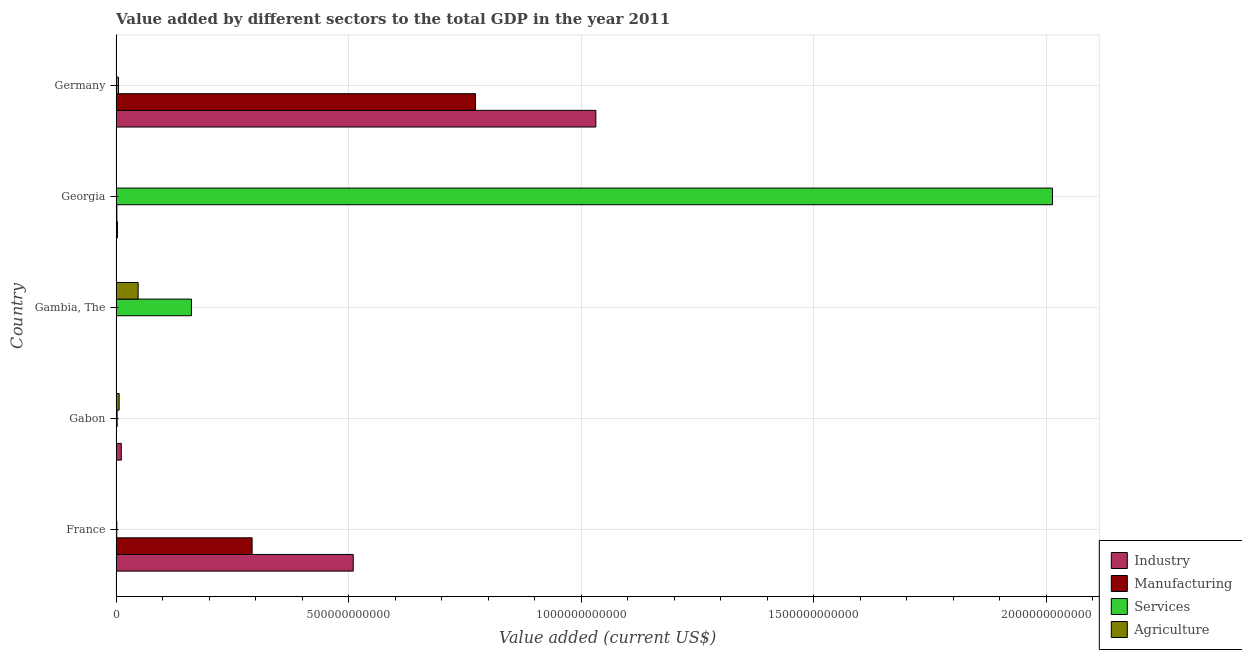How many groups of bars are there?
Your response must be concise. 5. Are the number of bars per tick equal to the number of legend labels?
Make the answer very short. Yes. Are the number of bars on each tick of the Y-axis equal?
Your answer should be very brief. Yes. In how many cases, is the number of bars for a given country not equal to the number of legend labels?
Your answer should be compact. 0. What is the value added by manufacturing sector in Gambia, The?
Provide a short and direct response. 4.95e+07. Across all countries, what is the maximum value added by industrial sector?
Your answer should be very brief. 1.03e+12. Across all countries, what is the minimum value added by industrial sector?
Offer a very short reply. 1.26e+08. In which country was the value added by agricultural sector maximum?
Your response must be concise. Gambia, The. In which country was the value added by services sector minimum?
Your answer should be very brief. France. What is the total value added by agricultural sector in the graph?
Provide a succinct answer. 5.50e+1. What is the difference between the value added by services sector in Georgia and that in Germany?
Your response must be concise. 2.01e+12. What is the difference between the value added by manufacturing sector in Gambia, The and the value added by agricultural sector in Germany?
Your answer should be very brief. -1.52e+08. What is the average value added by industrial sector per country?
Keep it short and to the point. 3.11e+11. What is the difference between the value added by industrial sector and value added by agricultural sector in France?
Your answer should be compact. 5.10e+11. In how many countries, is the value added by manufacturing sector greater than 1000000000000 US$?
Your response must be concise. 0. What is the ratio of the value added by agricultural sector in Gambia, The to that in Georgia?
Your answer should be very brief. 75.81. Is the difference between the value added by agricultural sector in France and Gabon greater than the difference between the value added by services sector in France and Gabon?
Your answer should be compact. No. What is the difference between the highest and the second highest value added by agricultural sector?
Give a very brief answer. 4.09e+1. What is the difference between the highest and the lowest value added by agricultural sector?
Give a very brief answer. 4.71e+1. Is the sum of the value added by agricultural sector in Gambia, The and Germany greater than the maximum value added by services sector across all countries?
Provide a succinct answer. No. What does the 1st bar from the top in Gabon represents?
Offer a very short reply. Agriculture. What does the 4th bar from the bottom in Georgia represents?
Your answer should be compact. Agriculture. How many bars are there?
Give a very brief answer. 20. How many countries are there in the graph?
Provide a short and direct response. 5. What is the difference between two consecutive major ticks on the X-axis?
Make the answer very short. 5.00e+11. Does the graph contain any zero values?
Offer a terse response. No. Does the graph contain grids?
Provide a succinct answer. Yes. How are the legend labels stacked?
Offer a terse response. Vertical. What is the title of the graph?
Your response must be concise. Value added by different sectors to the total GDP in the year 2011. What is the label or title of the X-axis?
Your response must be concise. Value added (current US$). What is the Value added (current US$) of Industry in France?
Give a very brief answer. 5.10e+11. What is the Value added (current US$) in Manufacturing in France?
Offer a terse response. 2.92e+11. What is the Value added (current US$) of Services in France?
Offer a terse response. 1.45e+09. What is the Value added (current US$) in Agriculture in France?
Offer a very short reply. 3.48e+08. What is the Value added (current US$) of Industry in Gabon?
Offer a very short reply. 1.11e+1. What is the Value added (current US$) of Manufacturing in Gabon?
Your answer should be compact. 3.98e+08. What is the Value added (current US$) in Services in Gabon?
Provide a succinct answer. 2.20e+09. What is the Value added (current US$) of Agriculture in Gabon?
Provide a short and direct response. 6.46e+09. What is the Value added (current US$) of Industry in Gambia, The?
Make the answer very short. 1.26e+08. What is the Value added (current US$) of Manufacturing in Gambia, The?
Make the answer very short. 4.95e+07. What is the Value added (current US$) in Services in Gambia, The?
Provide a short and direct response. 1.62e+11. What is the Value added (current US$) of Agriculture in Gambia, The?
Offer a terse response. 4.73e+1. What is the Value added (current US$) in Industry in Georgia?
Make the answer very short. 2.87e+09. What is the Value added (current US$) of Manufacturing in Georgia?
Your response must be concise. 1.63e+09. What is the Value added (current US$) in Services in Georgia?
Provide a short and direct response. 2.01e+12. What is the Value added (current US$) in Agriculture in Georgia?
Offer a terse response. 6.24e+08. What is the Value added (current US$) in Industry in Germany?
Your response must be concise. 1.03e+12. What is the Value added (current US$) of Manufacturing in Germany?
Keep it short and to the point. 7.73e+11. What is the Value added (current US$) of Services in Germany?
Your response must be concise. 5.01e+09. What is the Value added (current US$) of Agriculture in Germany?
Your answer should be compact. 2.02e+08. Across all countries, what is the maximum Value added (current US$) of Industry?
Your answer should be very brief. 1.03e+12. Across all countries, what is the maximum Value added (current US$) in Manufacturing?
Ensure brevity in your answer.  7.73e+11. Across all countries, what is the maximum Value added (current US$) of Services?
Provide a short and direct response. 2.01e+12. Across all countries, what is the maximum Value added (current US$) in Agriculture?
Make the answer very short. 4.73e+1. Across all countries, what is the minimum Value added (current US$) of Industry?
Provide a short and direct response. 1.26e+08. Across all countries, what is the minimum Value added (current US$) in Manufacturing?
Provide a short and direct response. 4.95e+07. Across all countries, what is the minimum Value added (current US$) in Services?
Your response must be concise. 1.45e+09. Across all countries, what is the minimum Value added (current US$) in Agriculture?
Keep it short and to the point. 2.02e+08. What is the total Value added (current US$) of Industry in the graph?
Make the answer very short. 1.56e+12. What is the total Value added (current US$) of Manufacturing in the graph?
Your response must be concise. 1.07e+12. What is the total Value added (current US$) of Services in the graph?
Ensure brevity in your answer.  2.18e+12. What is the total Value added (current US$) in Agriculture in the graph?
Keep it short and to the point. 5.50e+1. What is the difference between the Value added (current US$) in Industry in France and that in Gabon?
Make the answer very short. 4.99e+11. What is the difference between the Value added (current US$) in Manufacturing in France and that in Gabon?
Make the answer very short. 2.92e+11. What is the difference between the Value added (current US$) of Services in France and that in Gabon?
Offer a terse response. -7.50e+08. What is the difference between the Value added (current US$) of Agriculture in France and that in Gabon?
Your answer should be compact. -6.11e+09. What is the difference between the Value added (current US$) in Industry in France and that in Gambia, The?
Offer a terse response. 5.10e+11. What is the difference between the Value added (current US$) of Manufacturing in France and that in Gambia, The?
Your answer should be very brief. 2.92e+11. What is the difference between the Value added (current US$) of Services in France and that in Gambia, The?
Keep it short and to the point. -1.61e+11. What is the difference between the Value added (current US$) in Agriculture in France and that in Gambia, The?
Make the answer very short. -4.70e+1. What is the difference between the Value added (current US$) of Industry in France and that in Georgia?
Provide a short and direct response. 5.07e+11. What is the difference between the Value added (current US$) of Manufacturing in France and that in Georgia?
Keep it short and to the point. 2.91e+11. What is the difference between the Value added (current US$) in Services in France and that in Georgia?
Make the answer very short. -2.01e+12. What is the difference between the Value added (current US$) of Agriculture in France and that in Georgia?
Ensure brevity in your answer.  -2.76e+08. What is the difference between the Value added (current US$) in Industry in France and that in Germany?
Provide a short and direct response. -5.22e+11. What is the difference between the Value added (current US$) of Manufacturing in France and that in Germany?
Offer a very short reply. -4.80e+11. What is the difference between the Value added (current US$) in Services in France and that in Germany?
Offer a very short reply. -3.56e+09. What is the difference between the Value added (current US$) in Agriculture in France and that in Germany?
Keep it short and to the point. 1.46e+08. What is the difference between the Value added (current US$) in Industry in Gabon and that in Gambia, The?
Make the answer very short. 1.09e+1. What is the difference between the Value added (current US$) in Manufacturing in Gabon and that in Gambia, The?
Keep it short and to the point. 3.48e+08. What is the difference between the Value added (current US$) in Services in Gabon and that in Gambia, The?
Offer a terse response. -1.60e+11. What is the difference between the Value added (current US$) of Agriculture in Gabon and that in Gambia, The?
Keep it short and to the point. -4.09e+1. What is the difference between the Value added (current US$) in Industry in Gabon and that in Georgia?
Provide a succinct answer. 8.20e+09. What is the difference between the Value added (current US$) of Manufacturing in Gabon and that in Georgia?
Offer a very short reply. -1.23e+09. What is the difference between the Value added (current US$) of Services in Gabon and that in Georgia?
Your answer should be compact. -2.01e+12. What is the difference between the Value added (current US$) in Agriculture in Gabon and that in Georgia?
Your response must be concise. 5.84e+09. What is the difference between the Value added (current US$) of Industry in Gabon and that in Germany?
Your response must be concise. -1.02e+12. What is the difference between the Value added (current US$) of Manufacturing in Gabon and that in Germany?
Give a very brief answer. -7.72e+11. What is the difference between the Value added (current US$) of Services in Gabon and that in Germany?
Provide a succinct answer. -2.81e+09. What is the difference between the Value added (current US$) in Agriculture in Gabon and that in Germany?
Provide a succinct answer. 6.26e+09. What is the difference between the Value added (current US$) in Industry in Gambia, The and that in Georgia?
Ensure brevity in your answer.  -2.75e+09. What is the difference between the Value added (current US$) of Manufacturing in Gambia, The and that in Georgia?
Make the answer very short. -1.58e+09. What is the difference between the Value added (current US$) of Services in Gambia, The and that in Georgia?
Keep it short and to the point. -1.85e+12. What is the difference between the Value added (current US$) of Agriculture in Gambia, The and that in Georgia?
Your answer should be compact. 4.67e+1. What is the difference between the Value added (current US$) in Industry in Gambia, The and that in Germany?
Provide a short and direct response. -1.03e+12. What is the difference between the Value added (current US$) of Manufacturing in Gambia, The and that in Germany?
Your answer should be very brief. -7.73e+11. What is the difference between the Value added (current US$) of Services in Gambia, The and that in Germany?
Give a very brief answer. 1.57e+11. What is the difference between the Value added (current US$) of Agriculture in Gambia, The and that in Germany?
Ensure brevity in your answer.  4.71e+1. What is the difference between the Value added (current US$) of Industry in Georgia and that in Germany?
Your answer should be very brief. -1.03e+12. What is the difference between the Value added (current US$) in Manufacturing in Georgia and that in Germany?
Offer a terse response. -7.71e+11. What is the difference between the Value added (current US$) in Services in Georgia and that in Germany?
Provide a succinct answer. 2.01e+12. What is the difference between the Value added (current US$) of Agriculture in Georgia and that in Germany?
Offer a terse response. 4.23e+08. What is the difference between the Value added (current US$) in Industry in France and the Value added (current US$) in Manufacturing in Gabon?
Your answer should be compact. 5.09e+11. What is the difference between the Value added (current US$) of Industry in France and the Value added (current US$) of Services in Gabon?
Provide a short and direct response. 5.08e+11. What is the difference between the Value added (current US$) of Industry in France and the Value added (current US$) of Agriculture in Gabon?
Offer a terse response. 5.03e+11. What is the difference between the Value added (current US$) in Manufacturing in France and the Value added (current US$) in Services in Gabon?
Provide a short and direct response. 2.90e+11. What is the difference between the Value added (current US$) in Manufacturing in France and the Value added (current US$) in Agriculture in Gabon?
Provide a succinct answer. 2.86e+11. What is the difference between the Value added (current US$) in Services in France and the Value added (current US$) in Agriculture in Gabon?
Your answer should be compact. -5.02e+09. What is the difference between the Value added (current US$) of Industry in France and the Value added (current US$) of Manufacturing in Gambia, The?
Offer a very short reply. 5.10e+11. What is the difference between the Value added (current US$) in Industry in France and the Value added (current US$) in Services in Gambia, The?
Ensure brevity in your answer.  3.48e+11. What is the difference between the Value added (current US$) in Industry in France and the Value added (current US$) in Agriculture in Gambia, The?
Your response must be concise. 4.63e+11. What is the difference between the Value added (current US$) of Manufacturing in France and the Value added (current US$) of Services in Gambia, The?
Provide a short and direct response. 1.30e+11. What is the difference between the Value added (current US$) in Manufacturing in France and the Value added (current US$) in Agriculture in Gambia, The?
Keep it short and to the point. 2.45e+11. What is the difference between the Value added (current US$) in Services in France and the Value added (current US$) in Agriculture in Gambia, The?
Offer a very short reply. -4.59e+1. What is the difference between the Value added (current US$) of Industry in France and the Value added (current US$) of Manufacturing in Georgia?
Give a very brief answer. 5.08e+11. What is the difference between the Value added (current US$) in Industry in France and the Value added (current US$) in Services in Georgia?
Your response must be concise. -1.50e+12. What is the difference between the Value added (current US$) in Industry in France and the Value added (current US$) in Agriculture in Georgia?
Give a very brief answer. 5.09e+11. What is the difference between the Value added (current US$) of Manufacturing in France and the Value added (current US$) of Services in Georgia?
Your answer should be compact. -1.72e+12. What is the difference between the Value added (current US$) of Manufacturing in France and the Value added (current US$) of Agriculture in Georgia?
Give a very brief answer. 2.92e+11. What is the difference between the Value added (current US$) of Services in France and the Value added (current US$) of Agriculture in Georgia?
Keep it short and to the point. 8.21e+08. What is the difference between the Value added (current US$) in Industry in France and the Value added (current US$) in Manufacturing in Germany?
Your answer should be very brief. -2.63e+11. What is the difference between the Value added (current US$) in Industry in France and the Value added (current US$) in Services in Germany?
Your answer should be compact. 5.05e+11. What is the difference between the Value added (current US$) of Industry in France and the Value added (current US$) of Agriculture in Germany?
Keep it short and to the point. 5.10e+11. What is the difference between the Value added (current US$) in Manufacturing in France and the Value added (current US$) in Services in Germany?
Keep it short and to the point. 2.87e+11. What is the difference between the Value added (current US$) in Manufacturing in France and the Value added (current US$) in Agriculture in Germany?
Offer a terse response. 2.92e+11. What is the difference between the Value added (current US$) in Services in France and the Value added (current US$) in Agriculture in Germany?
Your response must be concise. 1.24e+09. What is the difference between the Value added (current US$) of Industry in Gabon and the Value added (current US$) of Manufacturing in Gambia, The?
Keep it short and to the point. 1.10e+1. What is the difference between the Value added (current US$) in Industry in Gabon and the Value added (current US$) in Services in Gambia, The?
Offer a very short reply. -1.51e+11. What is the difference between the Value added (current US$) in Industry in Gabon and the Value added (current US$) in Agriculture in Gambia, The?
Provide a succinct answer. -3.63e+1. What is the difference between the Value added (current US$) in Manufacturing in Gabon and the Value added (current US$) in Services in Gambia, The?
Make the answer very short. -1.62e+11. What is the difference between the Value added (current US$) in Manufacturing in Gabon and the Value added (current US$) in Agriculture in Gambia, The?
Provide a succinct answer. -4.69e+1. What is the difference between the Value added (current US$) in Services in Gabon and the Value added (current US$) in Agriculture in Gambia, The?
Make the answer very short. -4.51e+1. What is the difference between the Value added (current US$) of Industry in Gabon and the Value added (current US$) of Manufacturing in Georgia?
Ensure brevity in your answer.  9.45e+09. What is the difference between the Value added (current US$) in Industry in Gabon and the Value added (current US$) in Services in Georgia?
Make the answer very short. -2.00e+12. What is the difference between the Value added (current US$) of Industry in Gabon and the Value added (current US$) of Agriculture in Georgia?
Offer a very short reply. 1.04e+1. What is the difference between the Value added (current US$) of Manufacturing in Gabon and the Value added (current US$) of Services in Georgia?
Your response must be concise. -2.01e+12. What is the difference between the Value added (current US$) in Manufacturing in Gabon and the Value added (current US$) in Agriculture in Georgia?
Provide a short and direct response. -2.26e+08. What is the difference between the Value added (current US$) in Services in Gabon and the Value added (current US$) in Agriculture in Georgia?
Make the answer very short. 1.57e+09. What is the difference between the Value added (current US$) in Industry in Gabon and the Value added (current US$) in Manufacturing in Germany?
Offer a very short reply. -7.62e+11. What is the difference between the Value added (current US$) in Industry in Gabon and the Value added (current US$) in Services in Germany?
Your answer should be compact. 6.07e+09. What is the difference between the Value added (current US$) of Industry in Gabon and the Value added (current US$) of Agriculture in Germany?
Ensure brevity in your answer.  1.09e+1. What is the difference between the Value added (current US$) in Manufacturing in Gabon and the Value added (current US$) in Services in Germany?
Keep it short and to the point. -4.61e+09. What is the difference between the Value added (current US$) in Manufacturing in Gabon and the Value added (current US$) in Agriculture in Germany?
Give a very brief answer. 1.96e+08. What is the difference between the Value added (current US$) of Services in Gabon and the Value added (current US$) of Agriculture in Germany?
Offer a very short reply. 1.99e+09. What is the difference between the Value added (current US$) of Industry in Gambia, The and the Value added (current US$) of Manufacturing in Georgia?
Make the answer very short. -1.50e+09. What is the difference between the Value added (current US$) of Industry in Gambia, The and the Value added (current US$) of Services in Georgia?
Keep it short and to the point. -2.01e+12. What is the difference between the Value added (current US$) of Industry in Gambia, The and the Value added (current US$) of Agriculture in Georgia?
Provide a succinct answer. -4.98e+08. What is the difference between the Value added (current US$) of Manufacturing in Gambia, The and the Value added (current US$) of Services in Georgia?
Your response must be concise. -2.01e+12. What is the difference between the Value added (current US$) in Manufacturing in Gambia, The and the Value added (current US$) in Agriculture in Georgia?
Keep it short and to the point. -5.75e+08. What is the difference between the Value added (current US$) in Services in Gambia, The and the Value added (current US$) in Agriculture in Georgia?
Ensure brevity in your answer.  1.61e+11. What is the difference between the Value added (current US$) of Industry in Gambia, The and the Value added (current US$) of Manufacturing in Germany?
Provide a short and direct response. -7.73e+11. What is the difference between the Value added (current US$) of Industry in Gambia, The and the Value added (current US$) of Services in Germany?
Keep it short and to the point. -4.88e+09. What is the difference between the Value added (current US$) of Industry in Gambia, The and the Value added (current US$) of Agriculture in Germany?
Ensure brevity in your answer.  -7.56e+07. What is the difference between the Value added (current US$) in Manufacturing in Gambia, The and the Value added (current US$) in Services in Germany?
Your answer should be very brief. -4.96e+09. What is the difference between the Value added (current US$) of Manufacturing in Gambia, The and the Value added (current US$) of Agriculture in Germany?
Ensure brevity in your answer.  -1.52e+08. What is the difference between the Value added (current US$) of Services in Gambia, The and the Value added (current US$) of Agriculture in Germany?
Your answer should be very brief. 1.62e+11. What is the difference between the Value added (current US$) in Industry in Georgia and the Value added (current US$) in Manufacturing in Germany?
Give a very brief answer. -7.70e+11. What is the difference between the Value added (current US$) of Industry in Georgia and the Value added (current US$) of Services in Germany?
Give a very brief answer. -2.13e+09. What is the difference between the Value added (current US$) of Industry in Georgia and the Value added (current US$) of Agriculture in Germany?
Your answer should be very brief. 2.67e+09. What is the difference between the Value added (current US$) in Manufacturing in Georgia and the Value added (current US$) in Services in Germany?
Your response must be concise. -3.38e+09. What is the difference between the Value added (current US$) in Manufacturing in Georgia and the Value added (current US$) in Agriculture in Germany?
Offer a terse response. 1.42e+09. What is the difference between the Value added (current US$) of Services in Georgia and the Value added (current US$) of Agriculture in Germany?
Provide a short and direct response. 2.01e+12. What is the average Value added (current US$) in Industry per country?
Provide a short and direct response. 3.11e+11. What is the average Value added (current US$) in Manufacturing per country?
Offer a terse response. 2.13e+11. What is the average Value added (current US$) of Services per country?
Offer a terse response. 4.37e+11. What is the average Value added (current US$) in Agriculture per country?
Make the answer very short. 1.10e+1. What is the difference between the Value added (current US$) of Industry and Value added (current US$) of Manufacturing in France?
Your answer should be compact. 2.17e+11. What is the difference between the Value added (current US$) of Industry and Value added (current US$) of Services in France?
Your answer should be very brief. 5.08e+11. What is the difference between the Value added (current US$) in Industry and Value added (current US$) in Agriculture in France?
Keep it short and to the point. 5.10e+11. What is the difference between the Value added (current US$) of Manufacturing and Value added (current US$) of Services in France?
Your answer should be compact. 2.91e+11. What is the difference between the Value added (current US$) in Manufacturing and Value added (current US$) in Agriculture in France?
Give a very brief answer. 2.92e+11. What is the difference between the Value added (current US$) of Services and Value added (current US$) of Agriculture in France?
Your response must be concise. 1.10e+09. What is the difference between the Value added (current US$) in Industry and Value added (current US$) in Manufacturing in Gabon?
Your response must be concise. 1.07e+1. What is the difference between the Value added (current US$) of Industry and Value added (current US$) of Services in Gabon?
Provide a short and direct response. 8.88e+09. What is the difference between the Value added (current US$) of Industry and Value added (current US$) of Agriculture in Gabon?
Provide a short and direct response. 4.61e+09. What is the difference between the Value added (current US$) of Manufacturing and Value added (current US$) of Services in Gabon?
Your answer should be very brief. -1.80e+09. What is the difference between the Value added (current US$) in Manufacturing and Value added (current US$) in Agriculture in Gabon?
Your response must be concise. -6.06e+09. What is the difference between the Value added (current US$) of Services and Value added (current US$) of Agriculture in Gabon?
Your answer should be compact. -4.27e+09. What is the difference between the Value added (current US$) of Industry and Value added (current US$) of Manufacturing in Gambia, The?
Your answer should be very brief. 7.65e+07. What is the difference between the Value added (current US$) in Industry and Value added (current US$) in Services in Gambia, The?
Keep it short and to the point. -1.62e+11. What is the difference between the Value added (current US$) in Industry and Value added (current US$) in Agriculture in Gambia, The?
Provide a short and direct response. -4.72e+1. What is the difference between the Value added (current US$) of Manufacturing and Value added (current US$) of Services in Gambia, The?
Make the answer very short. -1.62e+11. What is the difference between the Value added (current US$) in Manufacturing and Value added (current US$) in Agriculture in Gambia, The?
Provide a short and direct response. -4.73e+1. What is the difference between the Value added (current US$) in Services and Value added (current US$) in Agriculture in Gambia, The?
Your answer should be compact. 1.15e+11. What is the difference between the Value added (current US$) in Industry and Value added (current US$) in Manufacturing in Georgia?
Provide a succinct answer. 1.25e+09. What is the difference between the Value added (current US$) of Industry and Value added (current US$) of Services in Georgia?
Your response must be concise. -2.01e+12. What is the difference between the Value added (current US$) in Industry and Value added (current US$) in Agriculture in Georgia?
Keep it short and to the point. 2.25e+09. What is the difference between the Value added (current US$) in Manufacturing and Value added (current US$) in Services in Georgia?
Offer a terse response. -2.01e+12. What is the difference between the Value added (current US$) in Manufacturing and Value added (current US$) in Agriculture in Georgia?
Provide a short and direct response. 1.00e+09. What is the difference between the Value added (current US$) in Services and Value added (current US$) in Agriculture in Georgia?
Give a very brief answer. 2.01e+12. What is the difference between the Value added (current US$) of Industry and Value added (current US$) of Manufacturing in Germany?
Your answer should be compact. 2.59e+11. What is the difference between the Value added (current US$) of Industry and Value added (current US$) of Services in Germany?
Your response must be concise. 1.03e+12. What is the difference between the Value added (current US$) in Industry and Value added (current US$) in Agriculture in Germany?
Your answer should be compact. 1.03e+12. What is the difference between the Value added (current US$) of Manufacturing and Value added (current US$) of Services in Germany?
Your answer should be very brief. 7.68e+11. What is the difference between the Value added (current US$) of Manufacturing and Value added (current US$) of Agriculture in Germany?
Offer a terse response. 7.73e+11. What is the difference between the Value added (current US$) of Services and Value added (current US$) of Agriculture in Germany?
Provide a succinct answer. 4.80e+09. What is the ratio of the Value added (current US$) of Industry in France to that in Gabon?
Offer a terse response. 46.05. What is the ratio of the Value added (current US$) in Manufacturing in France to that in Gabon?
Your answer should be very brief. 735.23. What is the ratio of the Value added (current US$) in Services in France to that in Gabon?
Your response must be concise. 0.66. What is the ratio of the Value added (current US$) in Agriculture in France to that in Gabon?
Offer a terse response. 0.05. What is the ratio of the Value added (current US$) of Industry in France to that in Gambia, The?
Offer a very short reply. 4044.71. What is the ratio of the Value added (current US$) of Manufacturing in France to that in Gambia, The?
Give a very brief answer. 5902.08. What is the ratio of the Value added (current US$) in Services in France to that in Gambia, The?
Give a very brief answer. 0.01. What is the ratio of the Value added (current US$) in Agriculture in France to that in Gambia, The?
Your response must be concise. 0.01. What is the ratio of the Value added (current US$) in Industry in France to that in Georgia?
Provide a succinct answer. 177.38. What is the ratio of the Value added (current US$) of Manufacturing in France to that in Georgia?
Keep it short and to the point. 179.91. What is the ratio of the Value added (current US$) in Services in France to that in Georgia?
Ensure brevity in your answer.  0. What is the ratio of the Value added (current US$) in Agriculture in France to that in Georgia?
Keep it short and to the point. 0.56. What is the ratio of the Value added (current US$) of Industry in France to that in Germany?
Offer a very short reply. 0.49. What is the ratio of the Value added (current US$) of Manufacturing in France to that in Germany?
Offer a very short reply. 0.38. What is the ratio of the Value added (current US$) in Services in France to that in Germany?
Your answer should be compact. 0.29. What is the ratio of the Value added (current US$) of Agriculture in France to that in Germany?
Offer a terse response. 1.73. What is the ratio of the Value added (current US$) in Industry in Gabon to that in Gambia, The?
Offer a very short reply. 87.83. What is the ratio of the Value added (current US$) of Manufacturing in Gabon to that in Gambia, The?
Your response must be concise. 8.03. What is the ratio of the Value added (current US$) of Services in Gabon to that in Gambia, The?
Give a very brief answer. 0.01. What is the ratio of the Value added (current US$) in Agriculture in Gabon to that in Gambia, The?
Make the answer very short. 0.14. What is the ratio of the Value added (current US$) in Industry in Gabon to that in Georgia?
Your response must be concise. 3.85. What is the ratio of the Value added (current US$) in Manufacturing in Gabon to that in Georgia?
Provide a succinct answer. 0.24. What is the ratio of the Value added (current US$) of Services in Gabon to that in Georgia?
Offer a very short reply. 0. What is the ratio of the Value added (current US$) in Agriculture in Gabon to that in Georgia?
Offer a very short reply. 10.35. What is the ratio of the Value added (current US$) in Industry in Gabon to that in Germany?
Offer a very short reply. 0.01. What is the ratio of the Value added (current US$) in Manufacturing in Gabon to that in Germany?
Keep it short and to the point. 0. What is the ratio of the Value added (current US$) of Services in Gabon to that in Germany?
Offer a very short reply. 0.44. What is the ratio of the Value added (current US$) of Agriculture in Gabon to that in Germany?
Provide a short and direct response. 32.04. What is the ratio of the Value added (current US$) of Industry in Gambia, The to that in Georgia?
Make the answer very short. 0.04. What is the ratio of the Value added (current US$) of Manufacturing in Gambia, The to that in Georgia?
Offer a terse response. 0.03. What is the ratio of the Value added (current US$) in Services in Gambia, The to that in Georgia?
Give a very brief answer. 0.08. What is the ratio of the Value added (current US$) of Agriculture in Gambia, The to that in Georgia?
Keep it short and to the point. 75.81. What is the ratio of the Value added (current US$) of Industry in Gambia, The to that in Germany?
Provide a succinct answer. 0. What is the ratio of the Value added (current US$) of Services in Gambia, The to that in Germany?
Ensure brevity in your answer.  32.37. What is the ratio of the Value added (current US$) in Agriculture in Gambia, The to that in Germany?
Your answer should be compact. 234.65. What is the ratio of the Value added (current US$) in Industry in Georgia to that in Germany?
Offer a very short reply. 0. What is the ratio of the Value added (current US$) in Manufacturing in Georgia to that in Germany?
Provide a succinct answer. 0. What is the ratio of the Value added (current US$) of Services in Georgia to that in Germany?
Provide a succinct answer. 402.3. What is the ratio of the Value added (current US$) of Agriculture in Georgia to that in Germany?
Your answer should be compact. 3.1. What is the difference between the highest and the second highest Value added (current US$) of Industry?
Offer a terse response. 5.22e+11. What is the difference between the highest and the second highest Value added (current US$) in Manufacturing?
Offer a terse response. 4.80e+11. What is the difference between the highest and the second highest Value added (current US$) in Services?
Offer a terse response. 1.85e+12. What is the difference between the highest and the second highest Value added (current US$) in Agriculture?
Offer a terse response. 4.09e+1. What is the difference between the highest and the lowest Value added (current US$) in Industry?
Your answer should be very brief. 1.03e+12. What is the difference between the highest and the lowest Value added (current US$) in Manufacturing?
Your response must be concise. 7.73e+11. What is the difference between the highest and the lowest Value added (current US$) in Services?
Keep it short and to the point. 2.01e+12. What is the difference between the highest and the lowest Value added (current US$) of Agriculture?
Provide a succinct answer. 4.71e+1. 